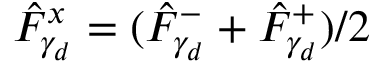<formula> <loc_0><loc_0><loc_500><loc_500>\hat { F } _ { \gamma _ { d } } ^ { x } = ( \hat { F } _ { \gamma _ { d } } ^ { - } + \hat { F } _ { \gamma _ { d } } ^ { + } ) / 2</formula> 